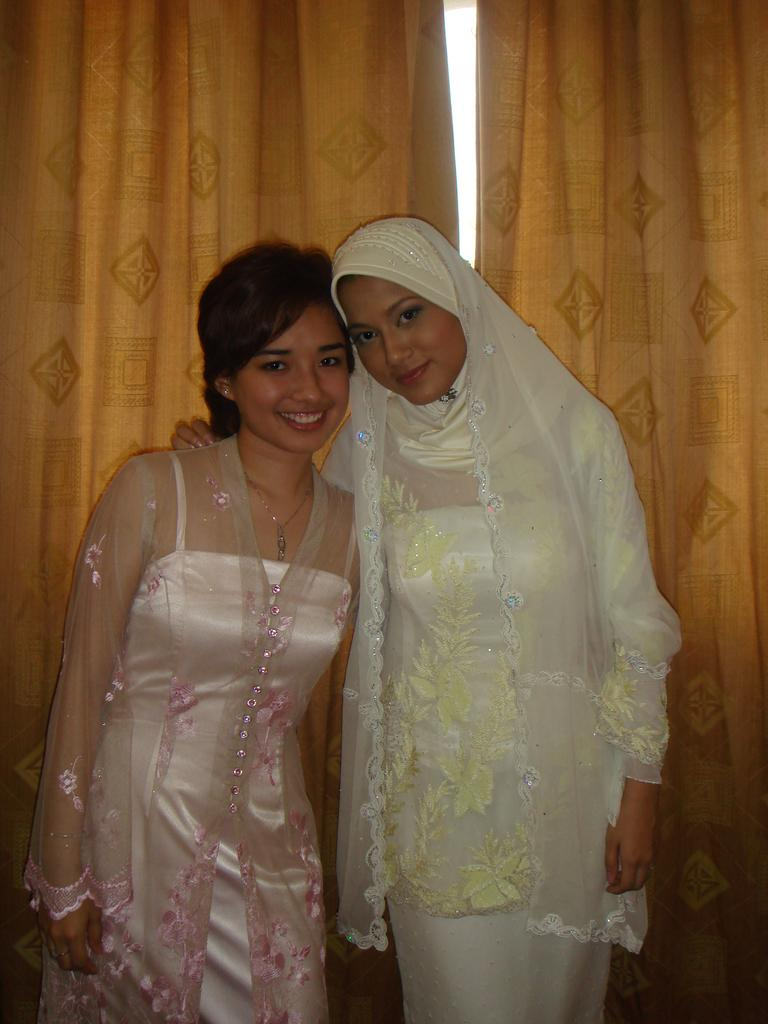How many people are present in the image? There are two persons in the image. What is located behind the two persons? There is a curtain behind the two persons. What type of list can be seen in the hands of one of the persons in the image? There is no list present in the image; only two persons and a curtain are visible. 